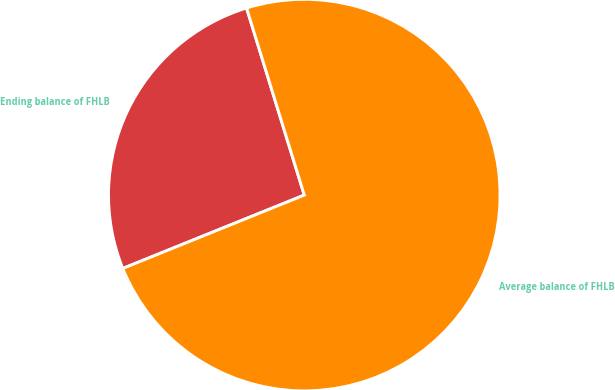Convert chart to OTSL. <chart><loc_0><loc_0><loc_500><loc_500><pie_chart><fcel>Ending balance of FHLB<fcel>Average balance of FHLB<nl><fcel>26.35%<fcel>73.65%<nl></chart> 